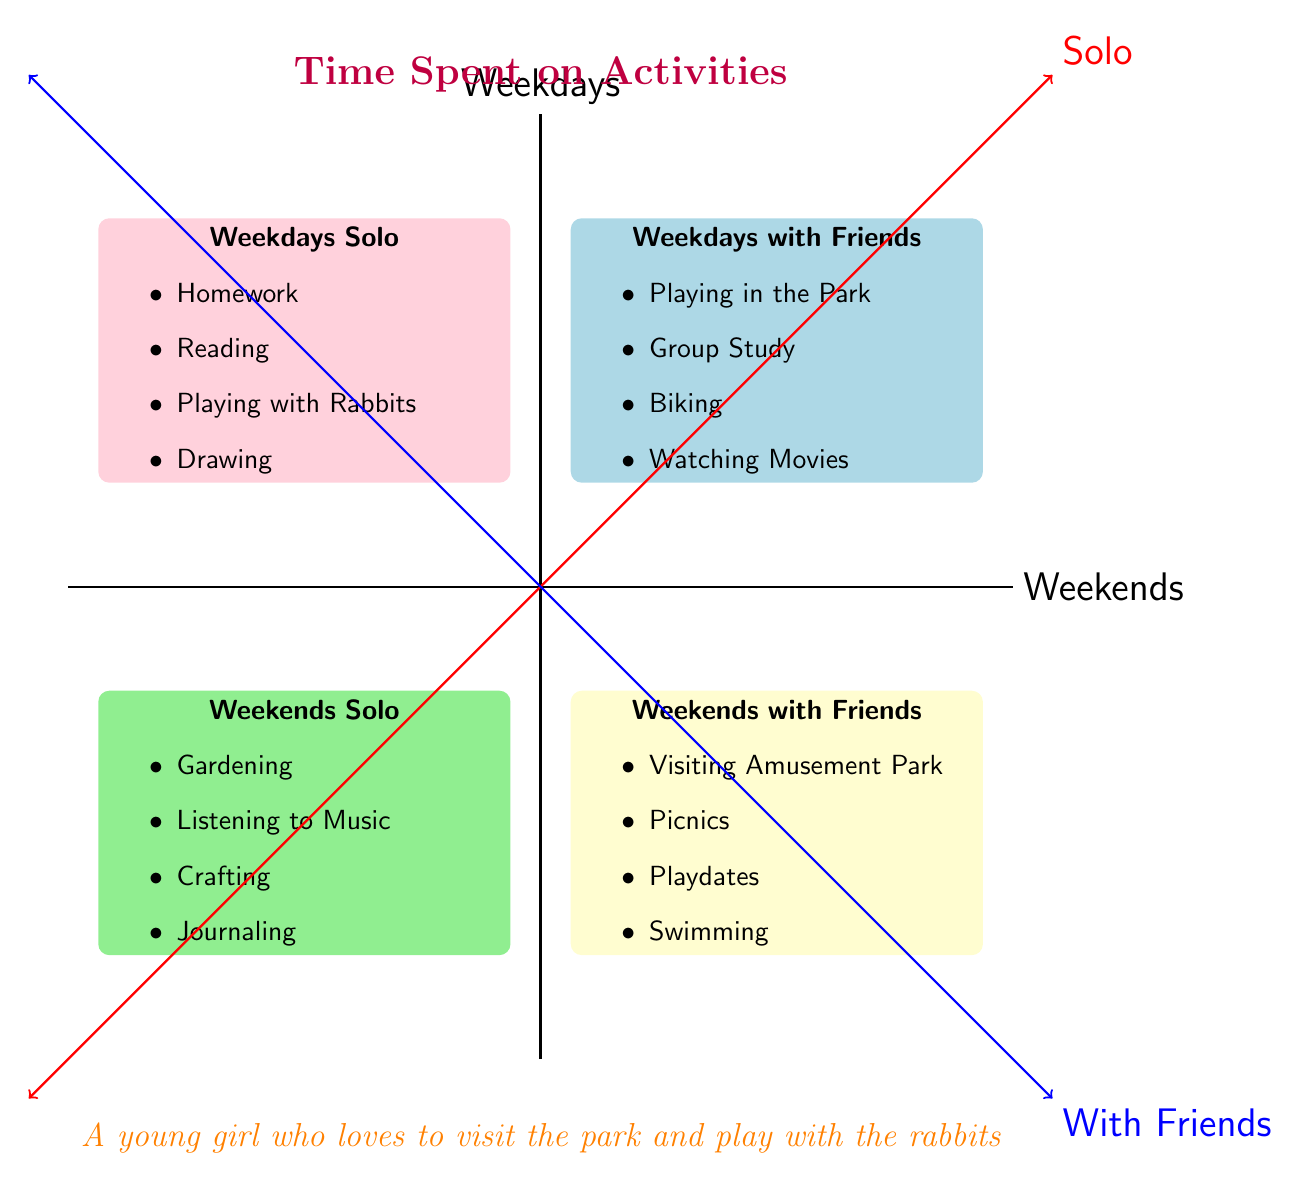What's in the Weekdays Solo quadrant? The Weekdays Solo quadrant lists activities including Homework, Reading, Playing with Rabbits, and Drawing, which are visually displayed in that section of the chart.
Answer: Homework, Reading, Playing with Rabbits, Drawing How many activities are listed in the Weekends with Friends quadrant? The Weekends with Friends quadrant contains four activities: Visiting Amusement Park, Picnics, Playdates, and Swimming, making a total of four activities.
Answer: 4 Which activity is in both Weekdays Solo and Weekends with Friends? The chart does not show any overlapping activities between the Weekdays Solo and Weekends with Friends quadrants, so there is no shared activity.
Answer: None What type of activities are more frequent on weekends? Examining the diagram, the Weekends with Friends quadrant includes fun outings like Visiting Amusement Park, whereas Weekdays focus more on academic or solitary activities. Thus, social activities with friends are highlighted on weekends.
Answer: Social Activities Compare the number of solo activities between weekdays and weekends. There are four solo activities listed in the Weekdays Solo quadrant and four solo activities in the Weekends Solo quadrant, leading to an equal comparison between the two.
Answer: Equal What quadrant includes Playing in the Park? The activity Playing in the Park is found in the Weekdays with Friends quadrant.
Answer: Weekdays with Friends Which quadrant shows the most creative activities? The Weekdays Solo quadrant features creative activities including Drawing and Playing with Rabbits, highlighting more artistic pursuits compared to others that are primarily social or recreational.
Answer: Weekdays Solo What is the main focus of the activities on weekdays? The diagram shows that the primary focus of activities on weekdays leans towards solitary tasks such as Homework and Reading, demonstrating a more academic nature.
Answer: Academic Tasks Where can I find activities related to gardening in the quadrant chart? Gardening is specifically located in the Weekends Solo quadrant, indicating it is a solo activity associated with weekends.
Answer: Weekends Solo 